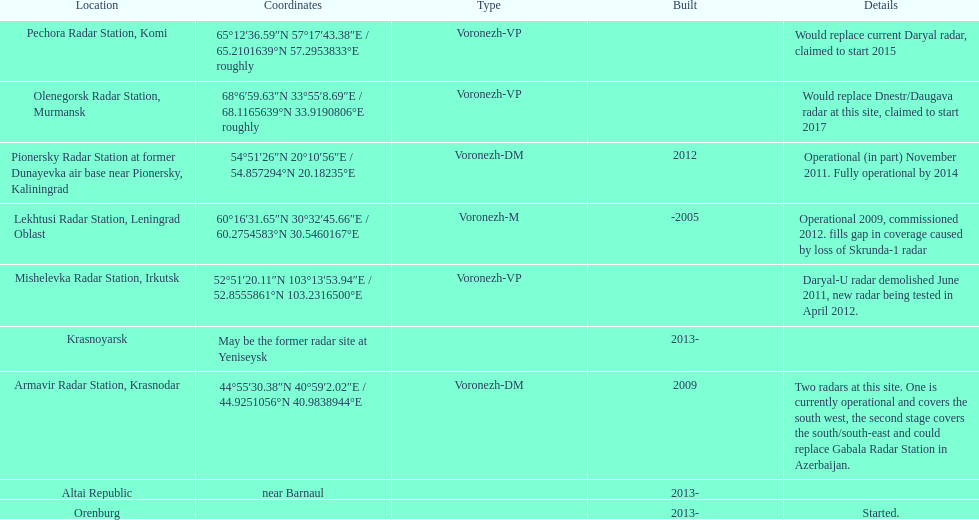What is the only radar that will start in 2015? Pechora Radar Station, Komi. 